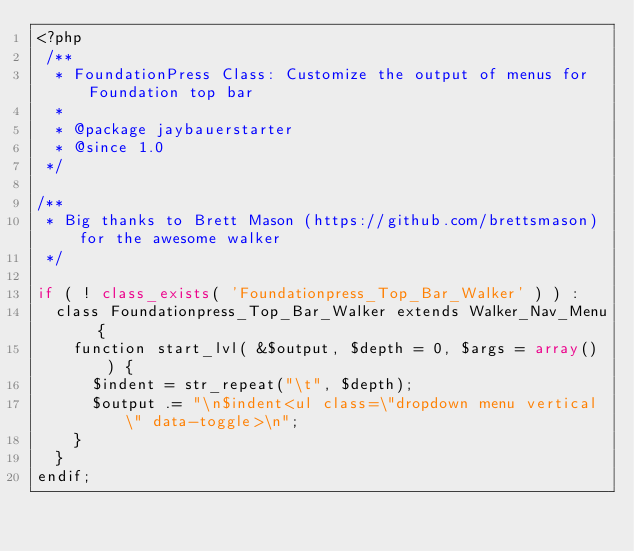<code> <loc_0><loc_0><loc_500><loc_500><_PHP_><?php
 /**
  * FoundationPress Class: Customize the output of menus for Foundation top bar
  *
  * @package jaybauerstarter
  * @since 1.0
 */

/**
 * Big thanks to Brett Mason (https://github.com/brettsmason) for the awesome walker
 */

if ( ! class_exists( 'Foundationpress_Top_Bar_Walker' ) ) :
	class Foundationpress_Top_Bar_Walker extends Walker_Nav_Menu {
		function start_lvl( &$output, $depth = 0, $args = array() ) {
			$indent = str_repeat("\t", $depth);
			$output .= "\n$indent<ul class=\"dropdown menu vertical\" data-toggle>\n";
		}
	}
endif;
</code> 